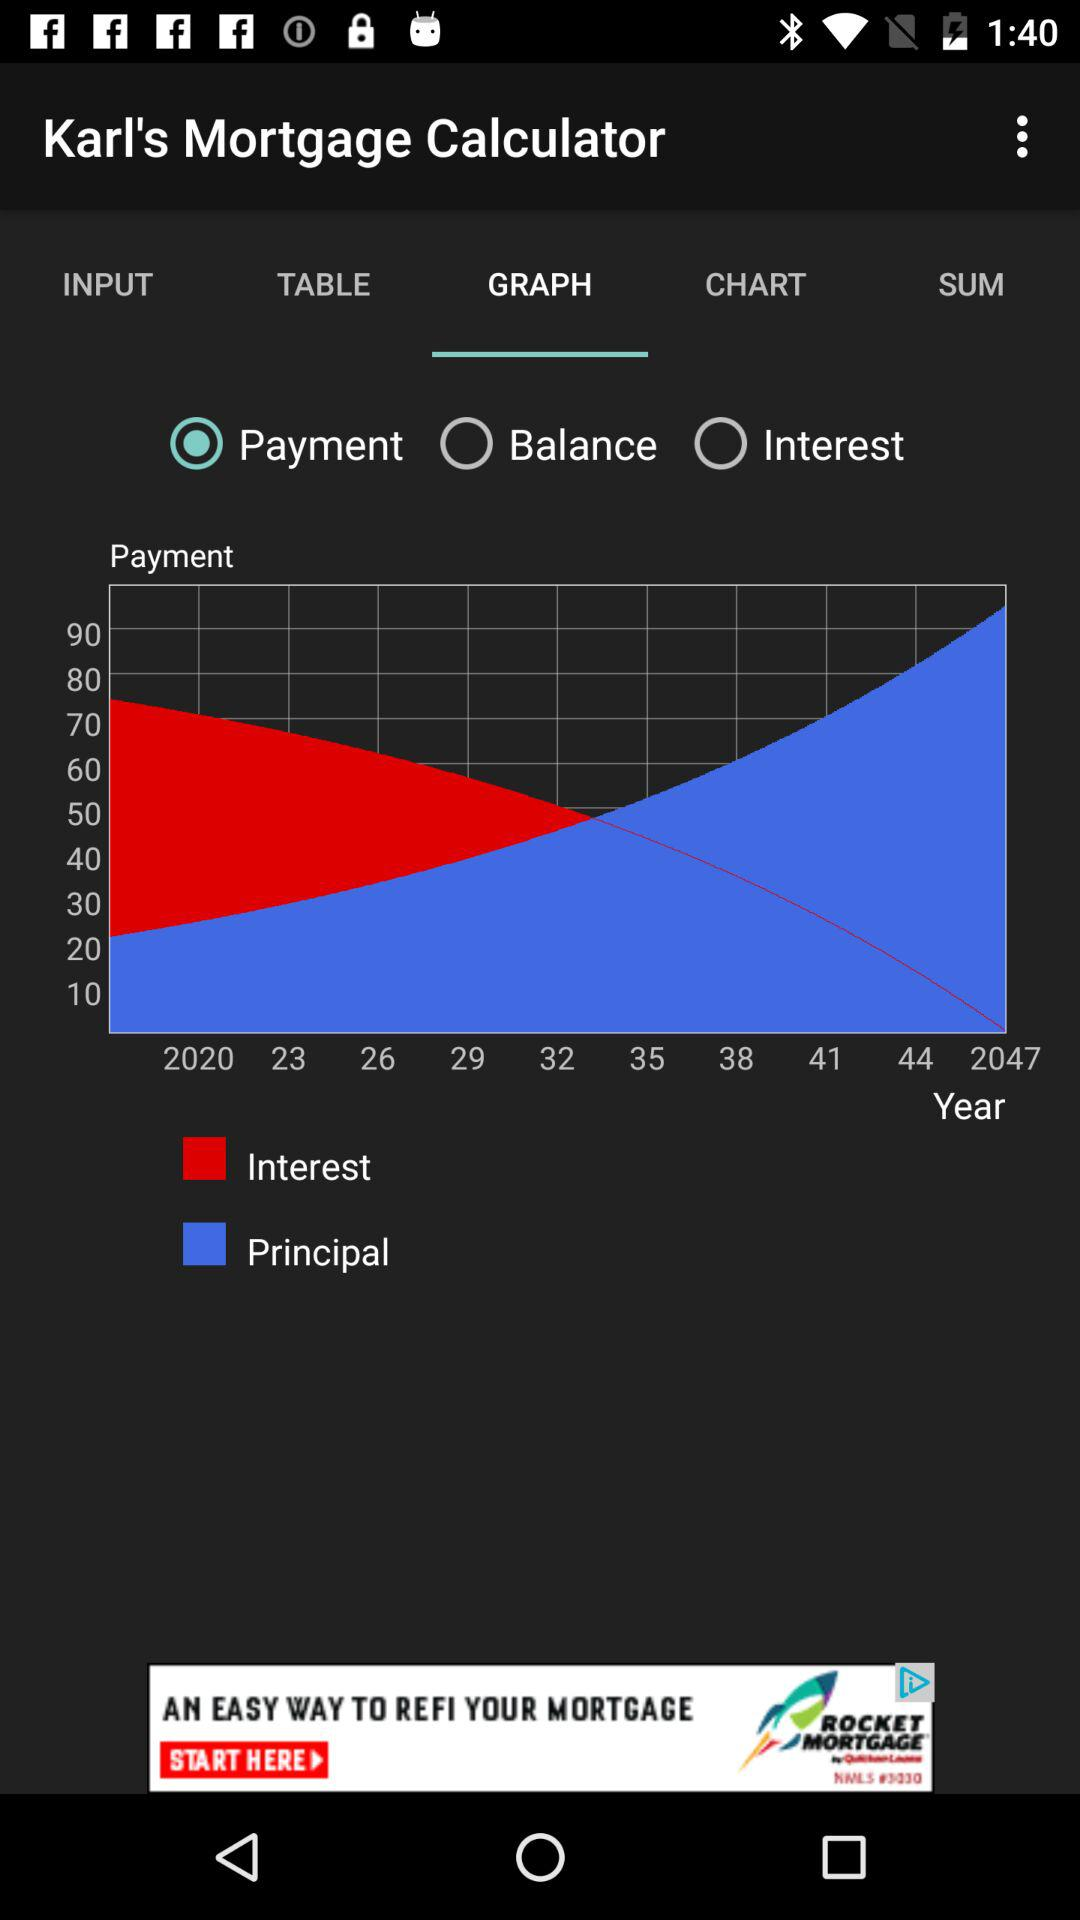What is shown in the graph as blue? The graph depicts the "Principal" as being blue. 